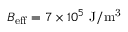Convert formula to latex. <formula><loc_0><loc_0><loc_500><loc_500>B _ { e f f } = 7 \times 1 0 ^ { 5 } J / m ^ { 3 }</formula> 